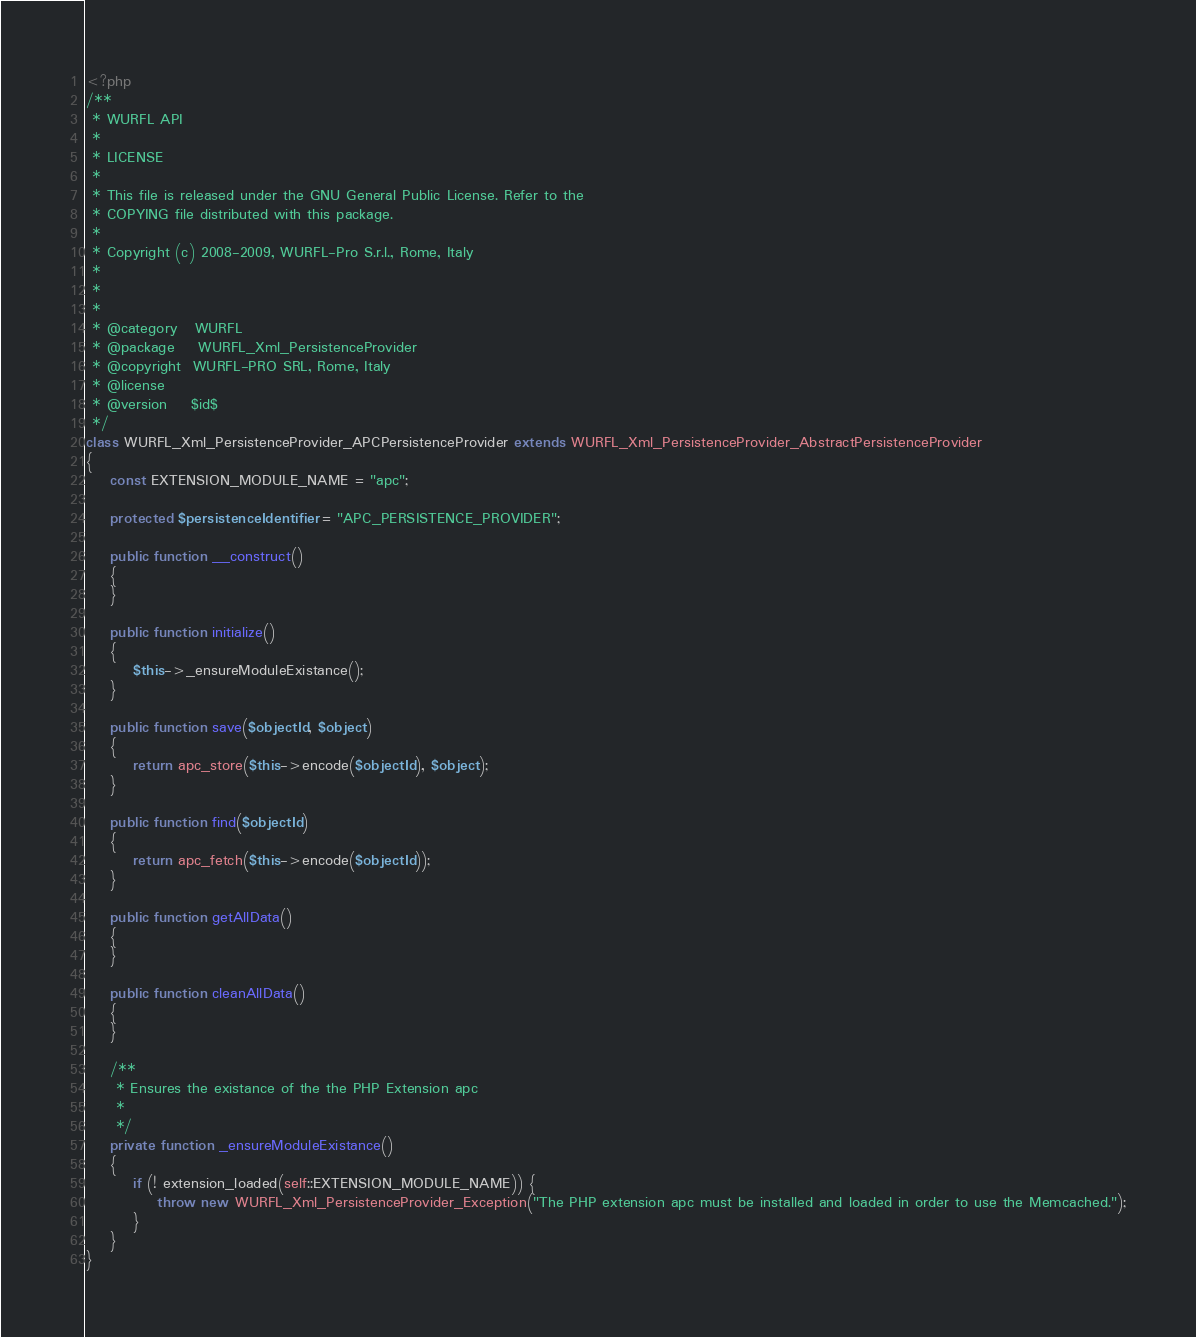<code> <loc_0><loc_0><loc_500><loc_500><_PHP_><?php
/**
 * WURFL API
 *
 * LICENSE
 *
 * This file is released under the GNU General Public License. Refer to the
 * COPYING file distributed with this package.
 *
 * Copyright (c) 2008-2009, WURFL-Pro S.r.l., Rome, Italy
 *
 *
 *
 * @category   WURFL
 * @package    WURFL_Xml_PersistenceProvider
 * @copyright  WURFL-PRO SRL, Rome, Italy
 * @license
 * @version    $id$
 */
class WURFL_Xml_PersistenceProvider_APCPersistenceProvider extends WURFL_Xml_PersistenceProvider_AbstractPersistenceProvider
{
    const EXTENSION_MODULE_NAME = "apc";
    
    protected $persistenceIdentifier = "APC_PERSISTENCE_PROVIDER";
    
    public function __construct()
    {
    }
    
    public function initialize()
    {
        $this->_ensureModuleExistance();
    }
    
    public function save($objectId, $object)
    {
        return apc_store($this->encode($objectId), $object);
    }
    
    public function find($objectId)
    {
        return apc_fetch($this->encode($objectId));
    }
    
    public function getAllData()
    {
    }
    
    public function cleanAllData()
    {
    }
    
    /**
     * Ensures the existance of the the PHP Extension apc
     *
     */
    private function _ensureModuleExistance()
    {
        if (! extension_loaded(self::EXTENSION_MODULE_NAME)) {
            throw new WURFL_Xml_PersistenceProvider_Exception("The PHP extension apc must be installed and loaded in order to use the Memcached.");
        }
    }
}
</code> 